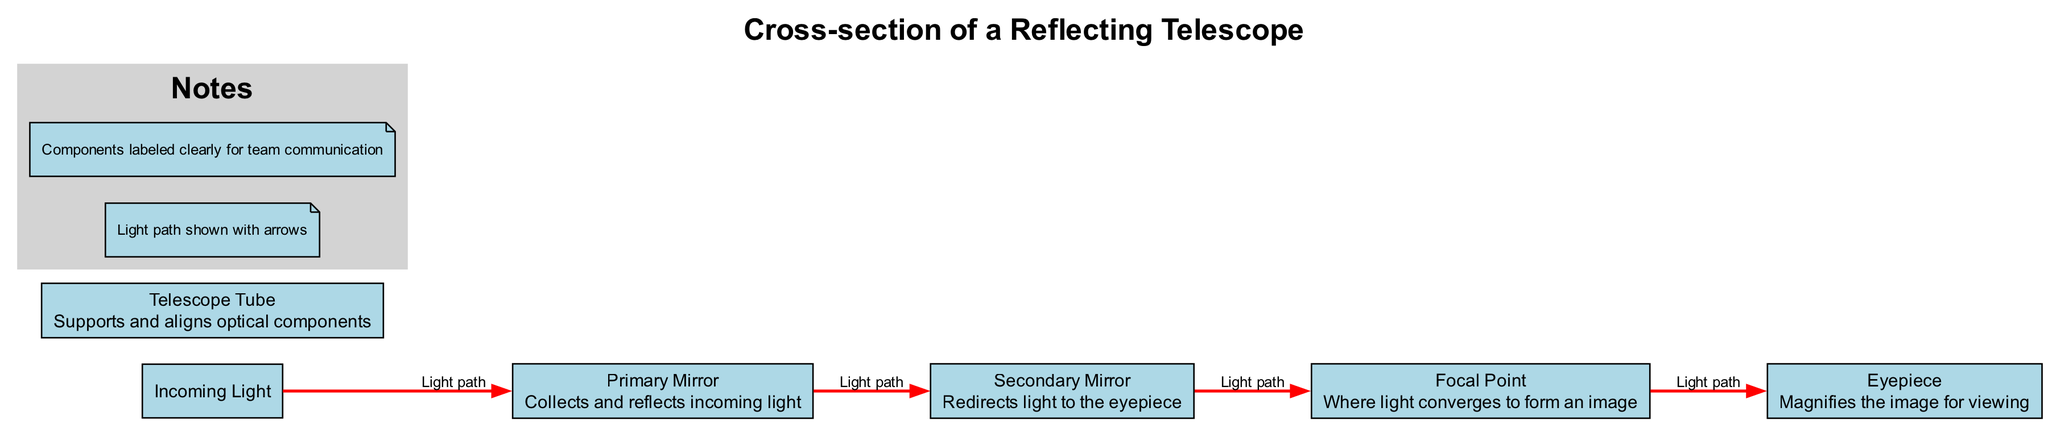What is the primary function of the Primary Mirror? The Primary Mirror is labeled in the diagram as the component that "Collects and reflects incoming light." This indicates that its main role is to gather the light that enters the telescope and reflect it for further processing.
Answer: Collects and reflects incoming light Which component redirects light to the eyepiece? In the diagram, the Secondary Mirror is identified as the component that "Redirects light to the eyepiece." This shows that it plays a crucial role in directing the gathered light to the viewing part of the telescope.
Answer: Secondary Mirror How many components are labeled in the diagram? The diagram clearly lists five components: Primary Mirror, Secondary Mirror, Eyepiece, Focal Point, and Telescope Tube. By counting these, we see that there are a total of five components.
Answer: Five What sequence does the light take from the Primary Mirror to the Eyepiece? Following the light path in the diagram: Light goes from the Primary Mirror to the Secondary Mirror, then to the Focal Point, and finally comes out through the Eyepiece. This sequence traces the path of light processing through the telescope.
Answer: Primary Mirror → Secondary Mirror → Focal Point → Eyepiece What is the purpose of the Eyepiece in the telescope? The Eyepiece, as described in the diagram, "Magnifies the image for viewing." Thus, its purpose is to enlarge the image that has been processed by the optical components for the observer to see clearly.
Answer: Magnifies the image for viewing What does the Focal Point signify in the diagram? The Focal Point is shown in the diagram as "Where light converges to form an image." This describes its role in the optical system, signifying the point at which light rays meet after reflecting off the mirrors to create an image.
Answer: Where light converges to form an image How is the light path represented in the diagram? The light path is represented with arrows in the diagram, indicating the direction of light flow between different components of the telescope. This visual representation helps in understanding how light travels through the system.
Answer: With arrows What component supports and aligns the optical components? The Telescope Tube is labeled in the diagram with the description "Supports and aligns optical components," indicating that this part is crucial for maintaining the structure and position of the other components.
Answer: Telescope Tube 